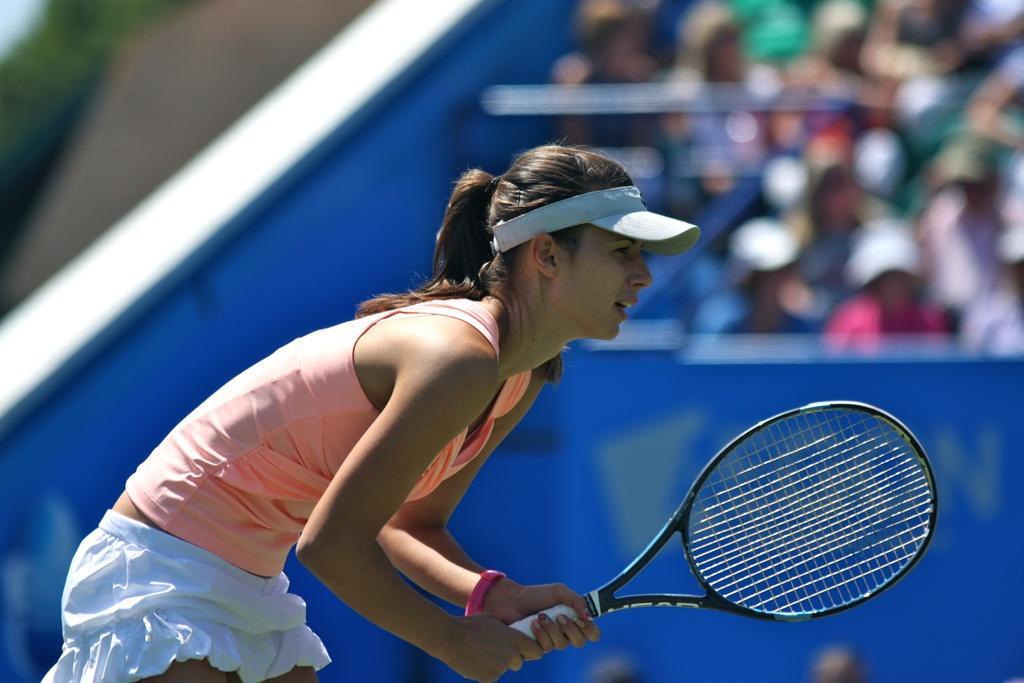How would you summarize this image in a sentence or two? In front of the picture, we see a woman is holding a racket in her hands. She might be playing the badminton. On the right side, we see a blue color board and the people are sitting on the chairs. In the background, it is in green, grey and blue color. This picture is blurred in the background. This picture might be clicked in the badminton court. 